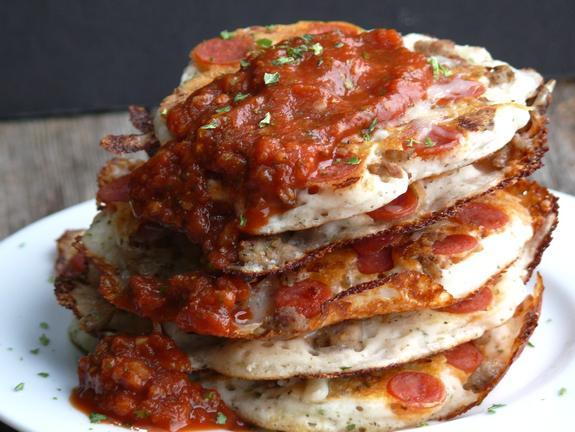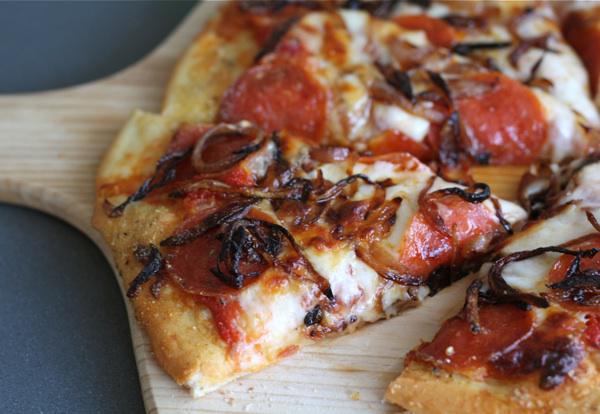The first image is the image on the left, the second image is the image on the right. Analyze the images presented: Is the assertion "In the left image, there is more than one individual pizza." valid? Answer yes or no. Yes. The first image is the image on the left, the second image is the image on the right. Examine the images to the left and right. Is the description "There is pepperoni on the table." accurate? Answer yes or no. No. 